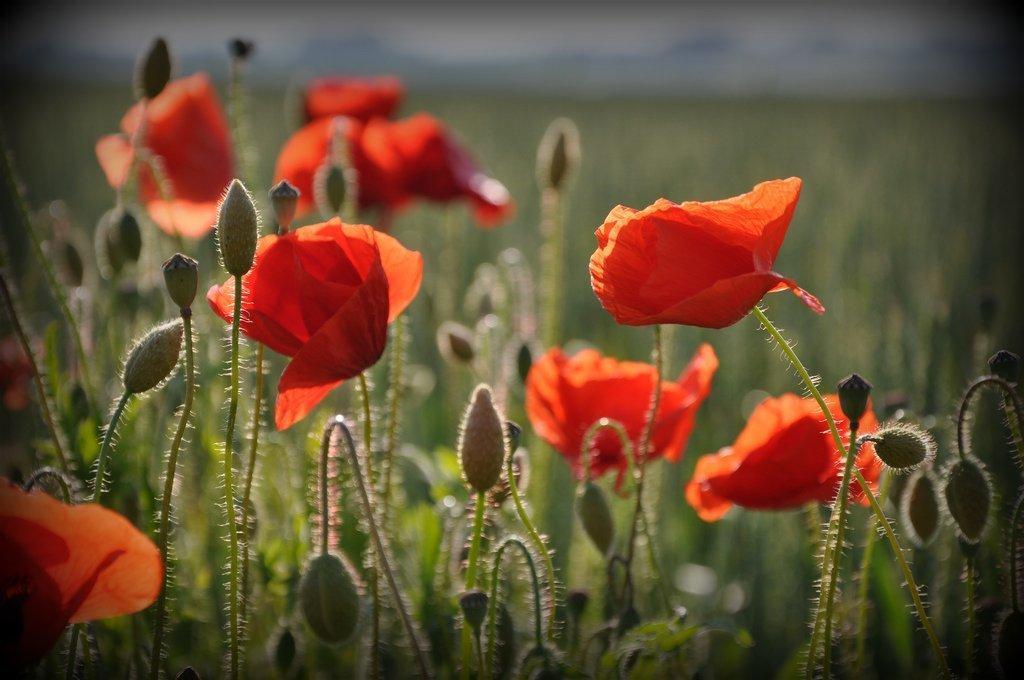Please provide a concise description of this image. In the image in the center, we can see plants and flowers, which are in orange color. 